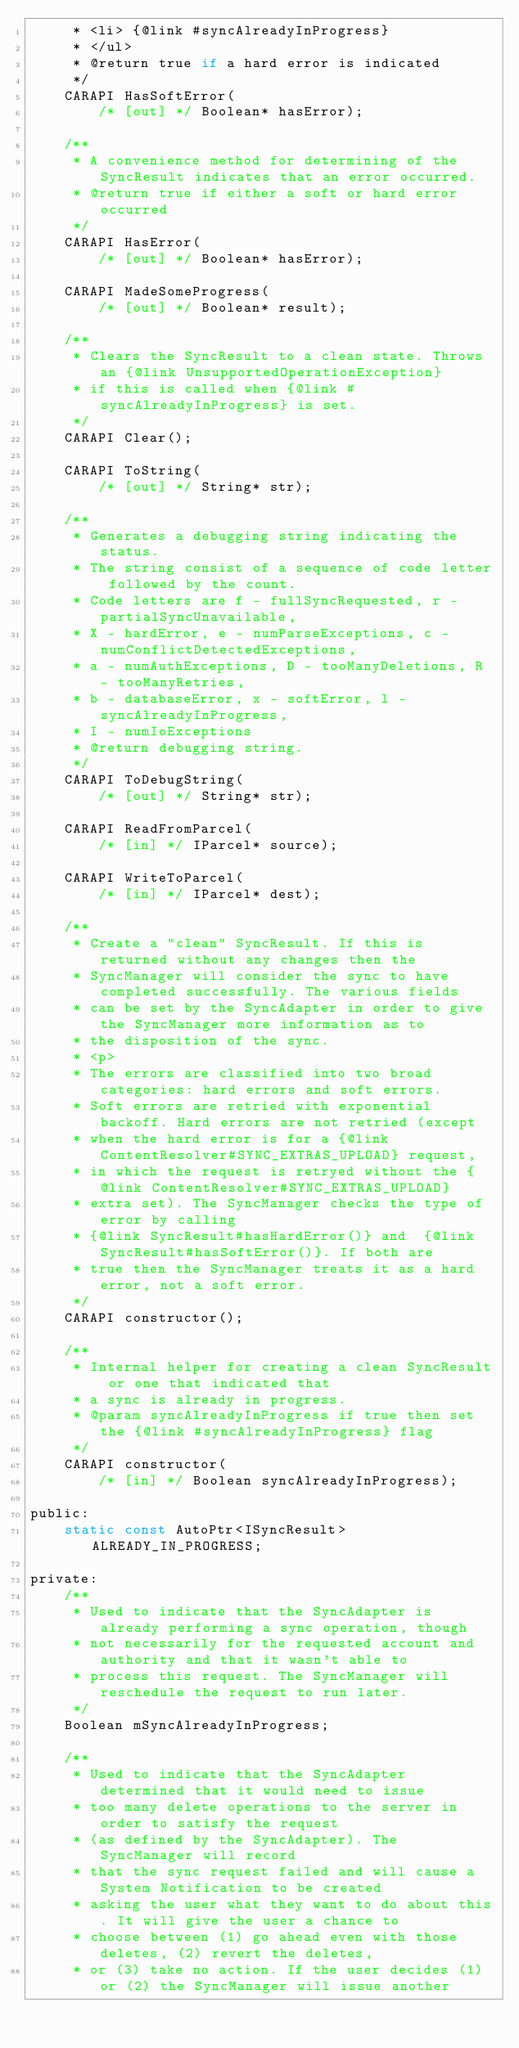Convert code to text. <code><loc_0><loc_0><loc_500><loc_500><_C_>     * <li> {@link #syncAlreadyInProgress}
     * </ul>
     * @return true if a hard error is indicated
     */
    CARAPI HasSoftError(
        /* [out] */ Boolean* hasError);

    /**
     * A convenience method for determining of the SyncResult indicates that an error occurred.
     * @return true if either a soft or hard error occurred
     */
    CARAPI HasError(
        /* [out] */ Boolean* hasError);

    CARAPI MadeSomeProgress(
        /* [out] */ Boolean* result);

    /**
     * Clears the SyncResult to a clean state. Throws an {@link UnsupportedOperationException}
     * if this is called when {@link #syncAlreadyInProgress} is set.
     */
    CARAPI Clear();

    CARAPI ToString(
        /* [out] */ String* str);

    /**
     * Generates a debugging string indicating the status.
     * The string consist of a sequence of code letter followed by the count.
     * Code letters are f - fullSyncRequested, r - partialSyncUnavailable,
     * X - hardError, e - numParseExceptions, c - numConflictDetectedExceptions,
     * a - numAuthExceptions, D - tooManyDeletions, R - tooManyRetries,
     * b - databaseError, x - softError, l - syncAlreadyInProgress,
     * I - numIoExceptions
     * @return debugging string.
     */
    CARAPI ToDebugString(
        /* [out] */ String* str);

    CARAPI ReadFromParcel(
        /* [in] */ IParcel* source);

    CARAPI WriteToParcel(
        /* [in] */ IParcel* dest);

    /**
     * Create a "clean" SyncResult. If this is returned without any changes then the
     * SyncManager will consider the sync to have completed successfully. The various fields
     * can be set by the SyncAdapter in order to give the SyncManager more information as to
     * the disposition of the sync.
     * <p>
     * The errors are classified into two broad categories: hard errors and soft errors.
     * Soft errors are retried with exponential backoff. Hard errors are not retried (except
     * when the hard error is for a {@link ContentResolver#SYNC_EXTRAS_UPLOAD} request,
     * in which the request is retryed without the {@link ContentResolver#SYNC_EXTRAS_UPLOAD}
     * extra set). The SyncManager checks the type of error by calling
     * {@link SyncResult#hasHardError()} and  {@link SyncResult#hasSoftError()}. If both are
     * true then the SyncManager treats it as a hard error, not a soft error.
     */
    CARAPI constructor();

    /**
     * Internal helper for creating a clean SyncResult or one that indicated that
     * a sync is already in progress.
     * @param syncAlreadyInProgress if true then set the {@link #syncAlreadyInProgress} flag
     */
    CARAPI constructor(
        /* [in] */ Boolean syncAlreadyInProgress);

public:
    static const AutoPtr<ISyncResult> ALREADY_IN_PROGRESS;

private:
    /**
     * Used to indicate that the SyncAdapter is already performing a sync operation, though
     * not necessarily for the requested account and authority and that it wasn't able to
     * process this request. The SyncManager will reschedule the request to run later.
     */
    Boolean mSyncAlreadyInProgress;

    /**
     * Used to indicate that the SyncAdapter determined that it would need to issue
     * too many delete operations to the server in order to satisfy the request
     * (as defined by the SyncAdapter). The SyncManager will record
     * that the sync request failed and will cause a System Notification to be created
     * asking the user what they want to do about this. It will give the user a chance to
     * choose between (1) go ahead even with those deletes, (2) revert the deletes,
     * or (3) take no action. If the user decides (1) or (2) the SyncManager will issue another</code> 